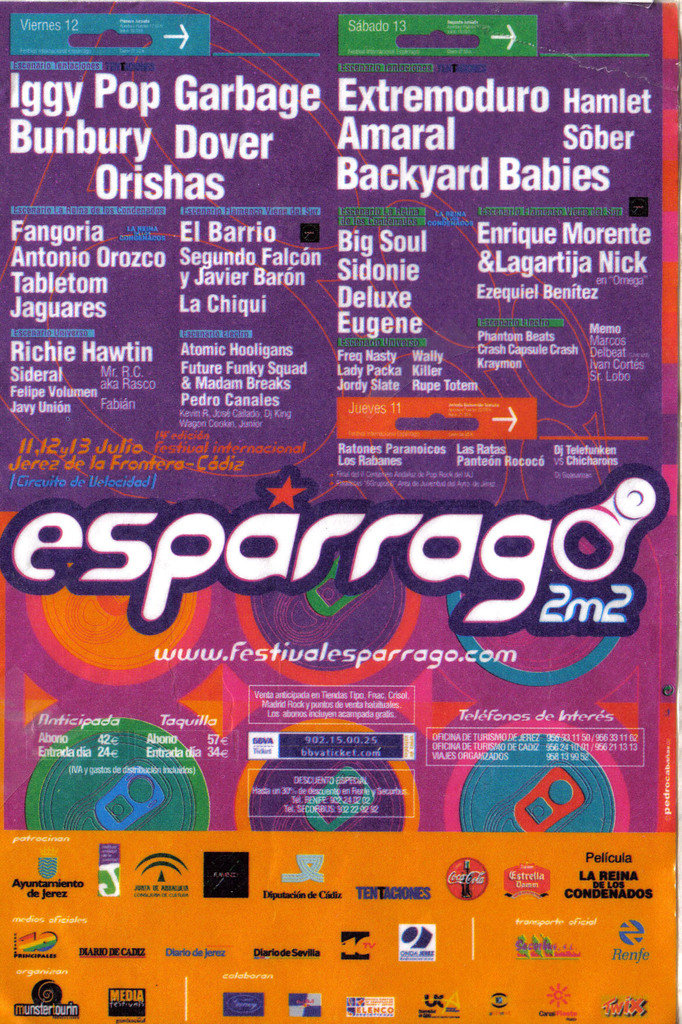Can you describe the design and visual elements seen in the poster? The design of the poster features a bold, psychedelic color palette with swirls of purple, orange, and blue, creating a dynamic and energetic atmosphere. Text is laid out in various fonts and sizes, echoing the vibrant and diverse nature of the event. Sponsor logos, like Coca-Cola and Estrella Damm, are also prominently displayed, contributing to the commercial aspect of the event. 